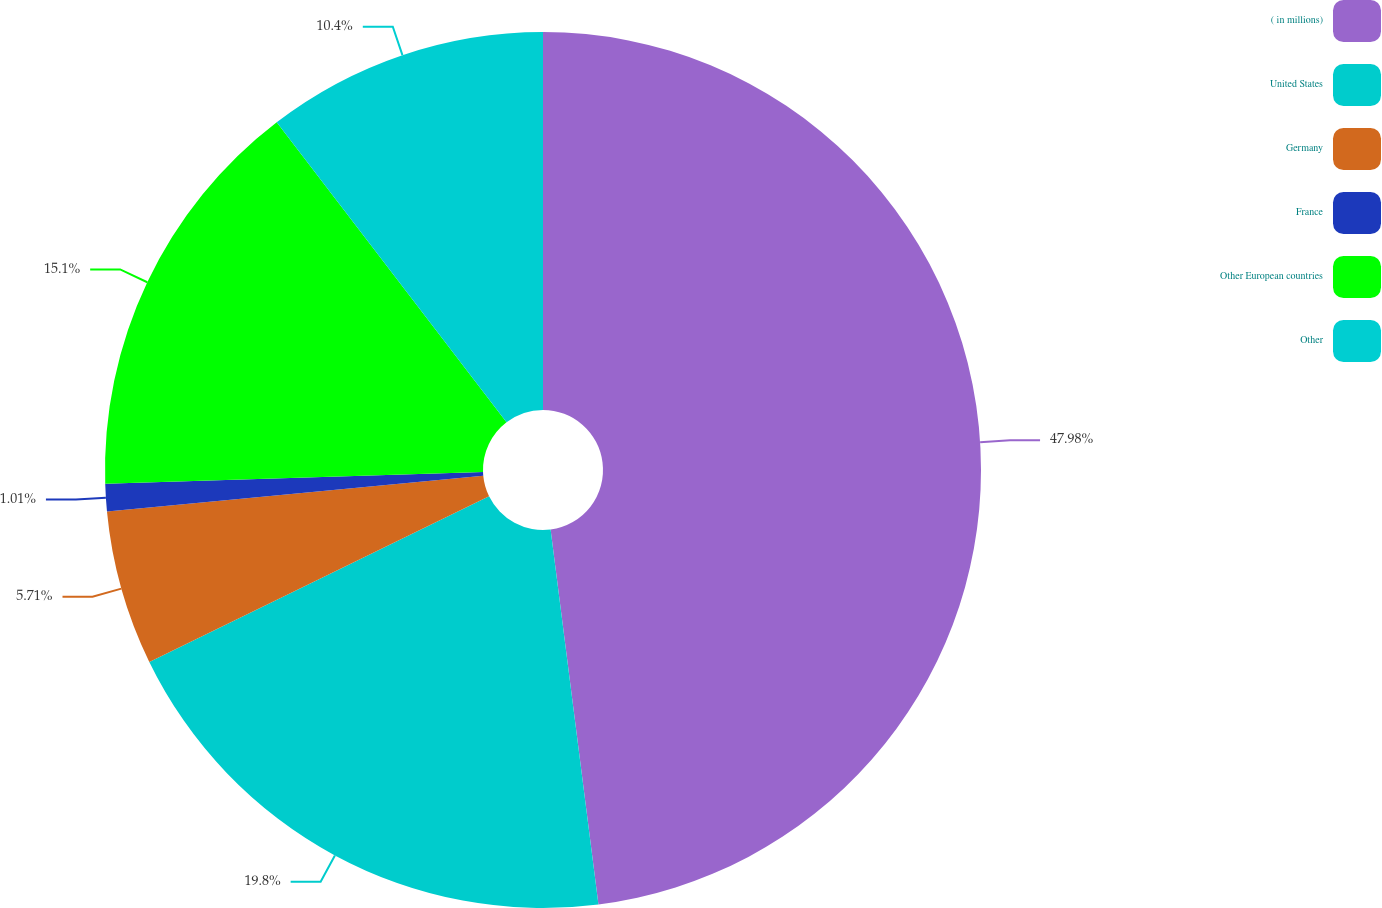Convert chart. <chart><loc_0><loc_0><loc_500><loc_500><pie_chart><fcel>( in millions)<fcel>United States<fcel>Germany<fcel>France<fcel>Other European countries<fcel>Other<nl><fcel>47.98%<fcel>19.8%<fcel>5.71%<fcel>1.01%<fcel>15.1%<fcel>10.4%<nl></chart> 